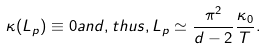Convert formula to latex. <formula><loc_0><loc_0><loc_500><loc_500>\kappa ( L _ { p } ) \equiv 0 a n d , t h u s , L _ { p } \simeq \frac { \pi ^ { 2 } } { d - 2 } \frac { \kappa _ { 0 } } { T } .</formula> 